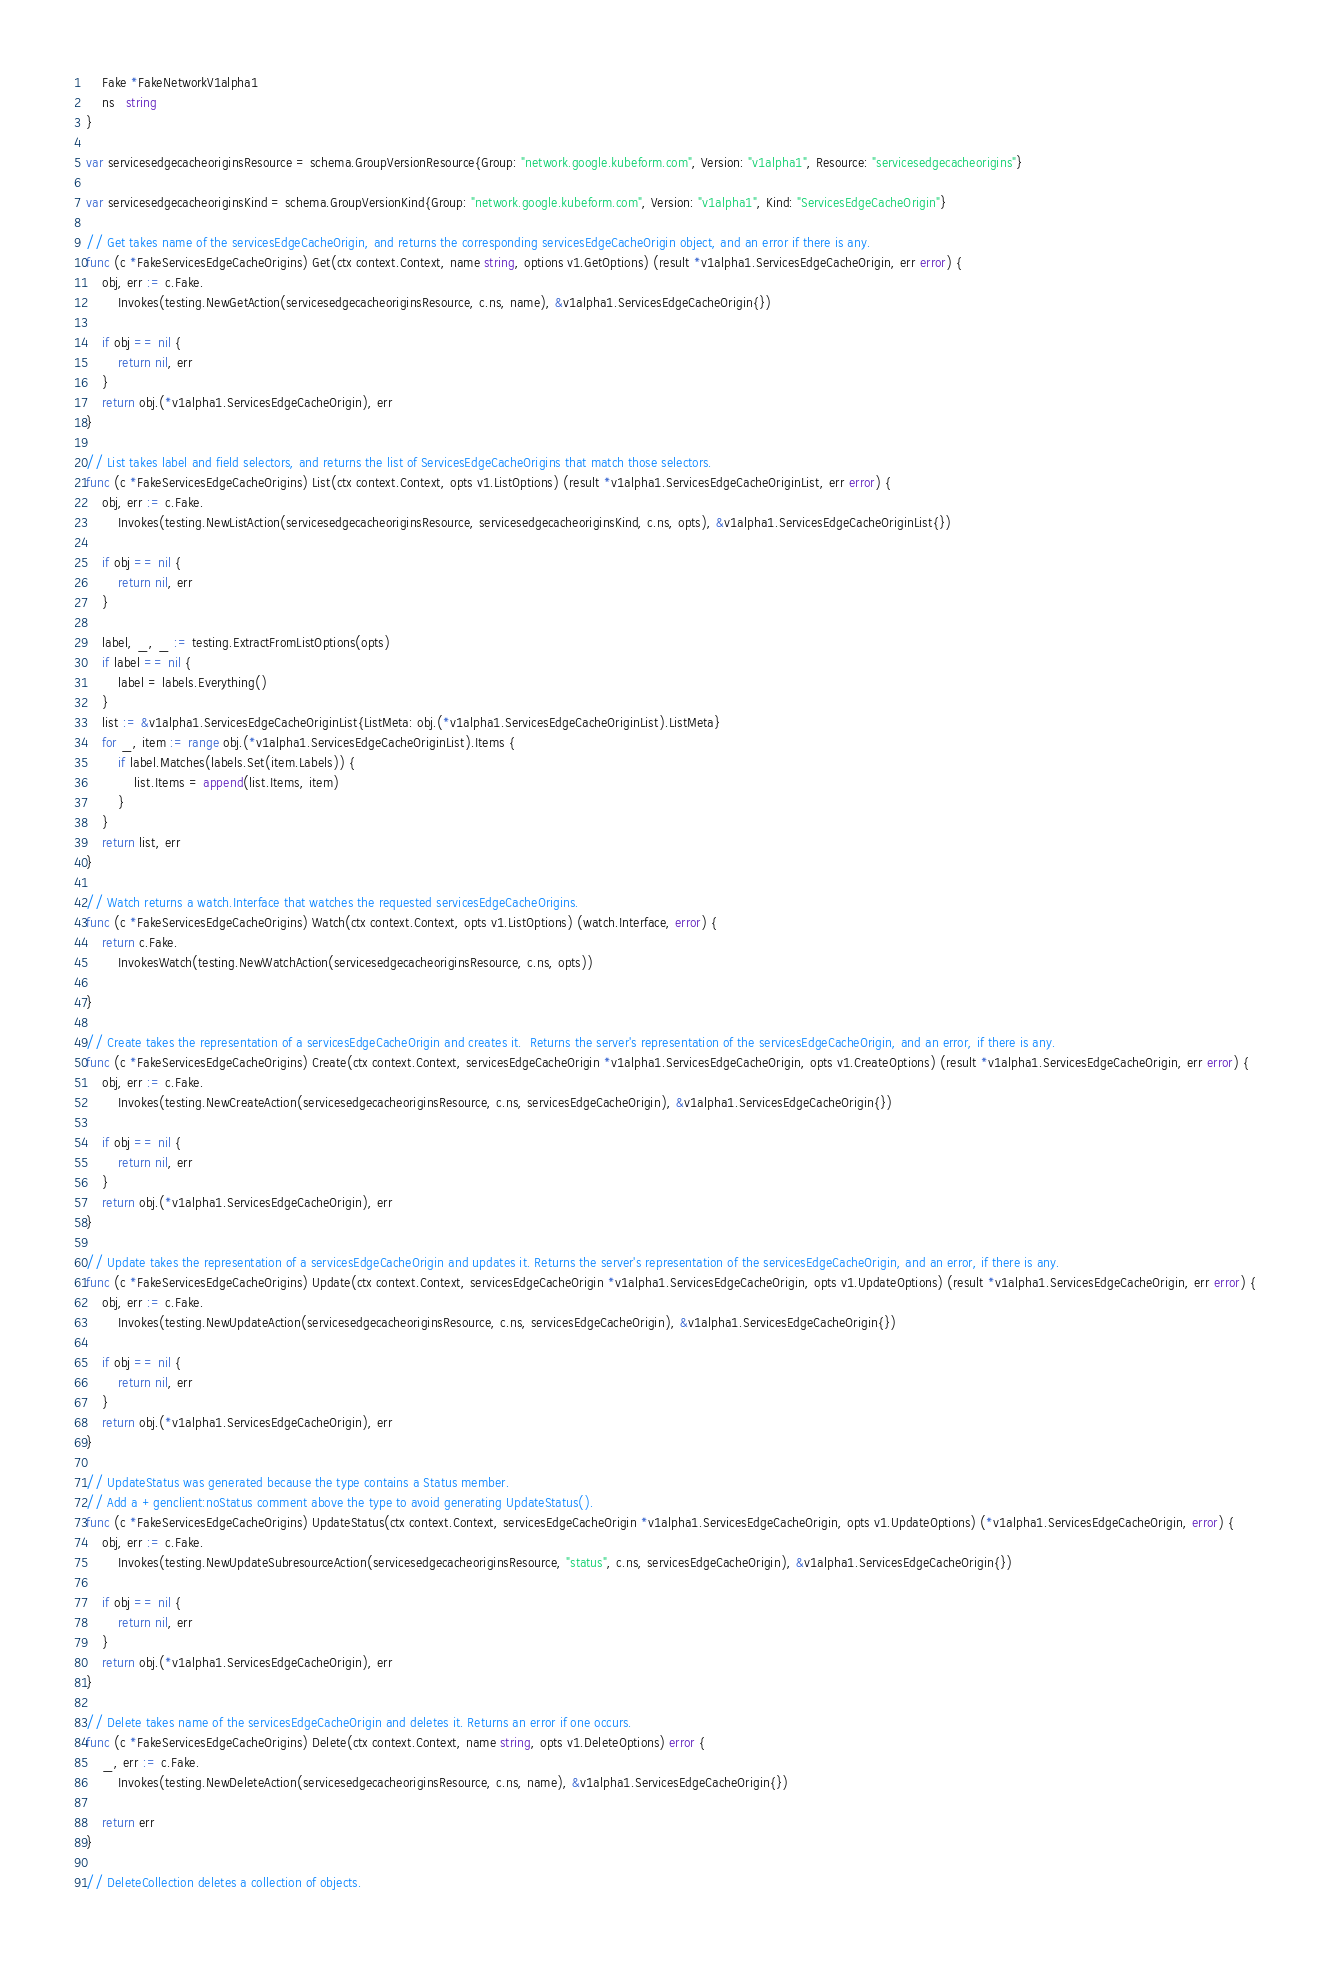Convert code to text. <code><loc_0><loc_0><loc_500><loc_500><_Go_>	Fake *FakeNetworkV1alpha1
	ns   string
}

var servicesedgecacheoriginsResource = schema.GroupVersionResource{Group: "network.google.kubeform.com", Version: "v1alpha1", Resource: "servicesedgecacheorigins"}

var servicesedgecacheoriginsKind = schema.GroupVersionKind{Group: "network.google.kubeform.com", Version: "v1alpha1", Kind: "ServicesEdgeCacheOrigin"}

// Get takes name of the servicesEdgeCacheOrigin, and returns the corresponding servicesEdgeCacheOrigin object, and an error if there is any.
func (c *FakeServicesEdgeCacheOrigins) Get(ctx context.Context, name string, options v1.GetOptions) (result *v1alpha1.ServicesEdgeCacheOrigin, err error) {
	obj, err := c.Fake.
		Invokes(testing.NewGetAction(servicesedgecacheoriginsResource, c.ns, name), &v1alpha1.ServicesEdgeCacheOrigin{})

	if obj == nil {
		return nil, err
	}
	return obj.(*v1alpha1.ServicesEdgeCacheOrigin), err
}

// List takes label and field selectors, and returns the list of ServicesEdgeCacheOrigins that match those selectors.
func (c *FakeServicesEdgeCacheOrigins) List(ctx context.Context, opts v1.ListOptions) (result *v1alpha1.ServicesEdgeCacheOriginList, err error) {
	obj, err := c.Fake.
		Invokes(testing.NewListAction(servicesedgecacheoriginsResource, servicesedgecacheoriginsKind, c.ns, opts), &v1alpha1.ServicesEdgeCacheOriginList{})

	if obj == nil {
		return nil, err
	}

	label, _, _ := testing.ExtractFromListOptions(opts)
	if label == nil {
		label = labels.Everything()
	}
	list := &v1alpha1.ServicesEdgeCacheOriginList{ListMeta: obj.(*v1alpha1.ServicesEdgeCacheOriginList).ListMeta}
	for _, item := range obj.(*v1alpha1.ServicesEdgeCacheOriginList).Items {
		if label.Matches(labels.Set(item.Labels)) {
			list.Items = append(list.Items, item)
		}
	}
	return list, err
}

// Watch returns a watch.Interface that watches the requested servicesEdgeCacheOrigins.
func (c *FakeServicesEdgeCacheOrigins) Watch(ctx context.Context, opts v1.ListOptions) (watch.Interface, error) {
	return c.Fake.
		InvokesWatch(testing.NewWatchAction(servicesedgecacheoriginsResource, c.ns, opts))

}

// Create takes the representation of a servicesEdgeCacheOrigin and creates it.  Returns the server's representation of the servicesEdgeCacheOrigin, and an error, if there is any.
func (c *FakeServicesEdgeCacheOrigins) Create(ctx context.Context, servicesEdgeCacheOrigin *v1alpha1.ServicesEdgeCacheOrigin, opts v1.CreateOptions) (result *v1alpha1.ServicesEdgeCacheOrigin, err error) {
	obj, err := c.Fake.
		Invokes(testing.NewCreateAction(servicesedgecacheoriginsResource, c.ns, servicesEdgeCacheOrigin), &v1alpha1.ServicesEdgeCacheOrigin{})

	if obj == nil {
		return nil, err
	}
	return obj.(*v1alpha1.ServicesEdgeCacheOrigin), err
}

// Update takes the representation of a servicesEdgeCacheOrigin and updates it. Returns the server's representation of the servicesEdgeCacheOrigin, and an error, if there is any.
func (c *FakeServicesEdgeCacheOrigins) Update(ctx context.Context, servicesEdgeCacheOrigin *v1alpha1.ServicesEdgeCacheOrigin, opts v1.UpdateOptions) (result *v1alpha1.ServicesEdgeCacheOrigin, err error) {
	obj, err := c.Fake.
		Invokes(testing.NewUpdateAction(servicesedgecacheoriginsResource, c.ns, servicesEdgeCacheOrigin), &v1alpha1.ServicesEdgeCacheOrigin{})

	if obj == nil {
		return nil, err
	}
	return obj.(*v1alpha1.ServicesEdgeCacheOrigin), err
}

// UpdateStatus was generated because the type contains a Status member.
// Add a +genclient:noStatus comment above the type to avoid generating UpdateStatus().
func (c *FakeServicesEdgeCacheOrigins) UpdateStatus(ctx context.Context, servicesEdgeCacheOrigin *v1alpha1.ServicesEdgeCacheOrigin, opts v1.UpdateOptions) (*v1alpha1.ServicesEdgeCacheOrigin, error) {
	obj, err := c.Fake.
		Invokes(testing.NewUpdateSubresourceAction(servicesedgecacheoriginsResource, "status", c.ns, servicesEdgeCacheOrigin), &v1alpha1.ServicesEdgeCacheOrigin{})

	if obj == nil {
		return nil, err
	}
	return obj.(*v1alpha1.ServicesEdgeCacheOrigin), err
}

// Delete takes name of the servicesEdgeCacheOrigin and deletes it. Returns an error if one occurs.
func (c *FakeServicesEdgeCacheOrigins) Delete(ctx context.Context, name string, opts v1.DeleteOptions) error {
	_, err := c.Fake.
		Invokes(testing.NewDeleteAction(servicesedgecacheoriginsResource, c.ns, name), &v1alpha1.ServicesEdgeCacheOrigin{})

	return err
}

// DeleteCollection deletes a collection of objects.</code> 